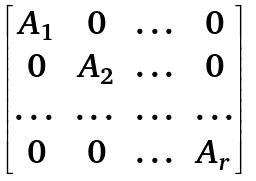Convert formula to latex. <formula><loc_0><loc_0><loc_500><loc_500>\begin{bmatrix} A _ { 1 } & 0 & \dots & 0 \\ 0 & A _ { 2 } & \dots & 0 \\ \dots & \dots & \dots & \dots \\ 0 & 0 & \dots & A _ { r } \end{bmatrix}</formula> 